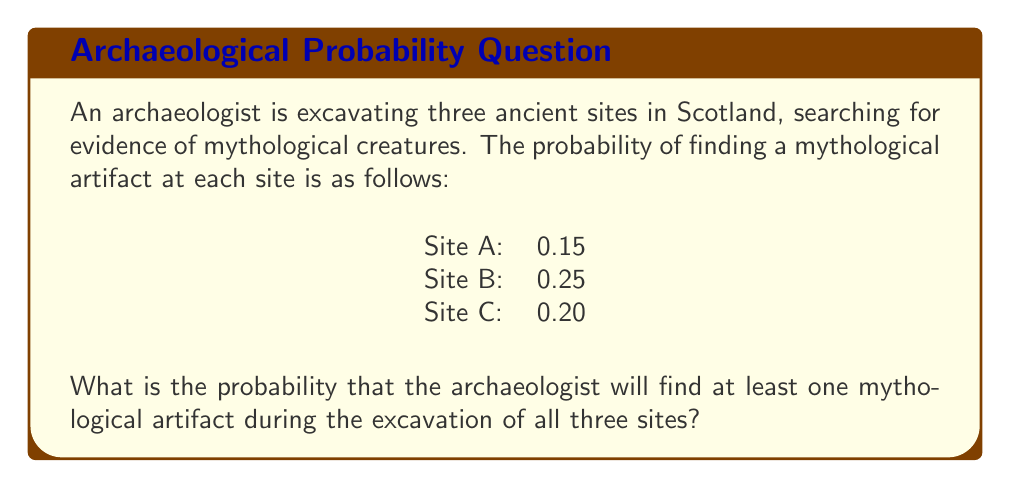Can you solve this math problem? To solve this problem, we'll use the complement method:

1) First, let's calculate the probability of not finding a mythological artifact at each site:

   Site A: $1 - 0.15 = 0.85$
   Site B: $1 - 0.25 = 0.75$
   Site C: $1 - 0.20 = 0.80$

2) The probability of not finding any mythological artifacts across all three sites is the product of these individual probabilities:

   $P(\text{no artifacts}) = 0.85 \times 0.75 \times 0.80 = 0.51$

3) Therefore, the probability of finding at least one mythological artifact is the complement of this probability:

   $P(\text{at least one artifact}) = 1 - P(\text{no artifacts})$
   
   $P(\text{at least one artifact}) = 1 - 0.51 = 0.49$

4) We can also express this as a percentage:

   $0.49 \times 100\% = 49\%$

Thus, the probability of finding at least one mythological artifact during the excavation of all three sites is 0.49 or 49%.
Answer: $0.49$ or $49\%$ 